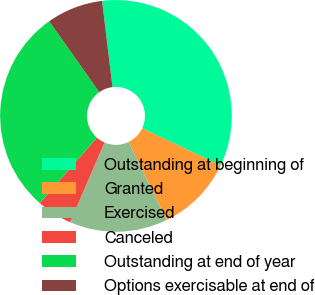<chart> <loc_0><loc_0><loc_500><loc_500><pie_chart><fcel>Outstanding at beginning of<fcel>Granted<fcel>Exercised<fcel>Canceled<fcel>Outstanding at end of year<fcel>Options exercisable at end of<nl><fcel>33.97%<fcel>10.76%<fcel>13.66%<fcel>4.96%<fcel>28.78%<fcel>7.86%<nl></chart> 